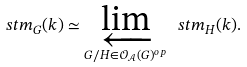<formula> <loc_0><loc_0><loc_500><loc_500>\ s t m _ { G } ( k ) \simeq \varprojlim _ { G / H \in \mathcal { O } _ { \mathcal { A } } ( G ) ^ { o p } } \ s t m _ { H } ( k ) .</formula> 